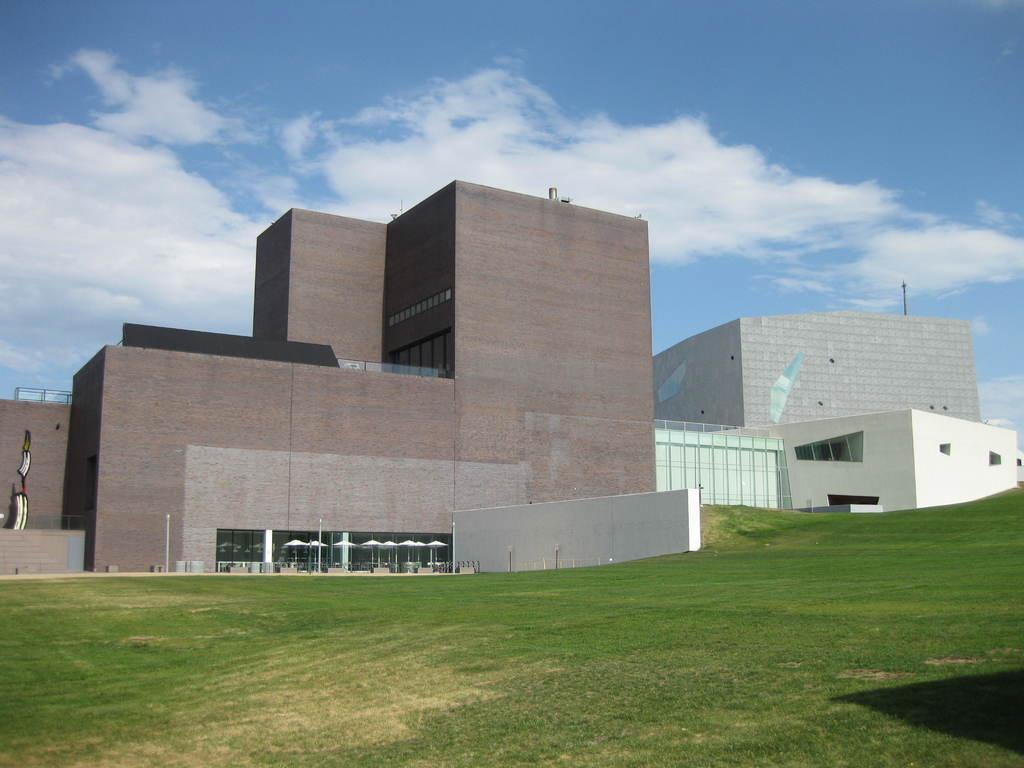What type of vegetation can be seen in the image? There is grass in the image. What type of structures are visible in the image? There are buildings in the image. What objects are present in the image that might provide shade? There are umbrellas in the image. What are the poles used for in the image? The poles might be used to support the umbrellas or other objects in the image. What is visible in the background of the image? The sky is visible in the background of the image. What can be seen in the sky? Clouds are present in the sky. What type of curtain can be seen hanging from the beast's window in the image? There is no beast or window present in the image, so there are no curtains to be seen. 